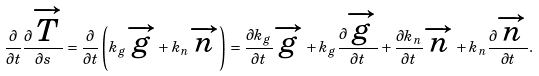Convert formula to latex. <formula><loc_0><loc_0><loc_500><loc_500>\frac { \partial } { \partial t } \frac { \partial \overrightarrow { T } } { \partial s } = \frac { \partial } { \partial t } \left ( { { k _ { g } } \overrightarrow { g } + { k _ { n } } \overrightarrow { n } } \right ) = \frac { { \partial { k _ { g } } } } { \partial t } \overrightarrow { g } + { k _ { g } } \frac { \partial \overrightarrow { g } } { \partial t } + \frac { { \partial { k _ { n } } } } { \partial t } \overrightarrow { n } + { k _ { n } } \frac { \partial \overrightarrow { n } } { \partial t } .</formula> 